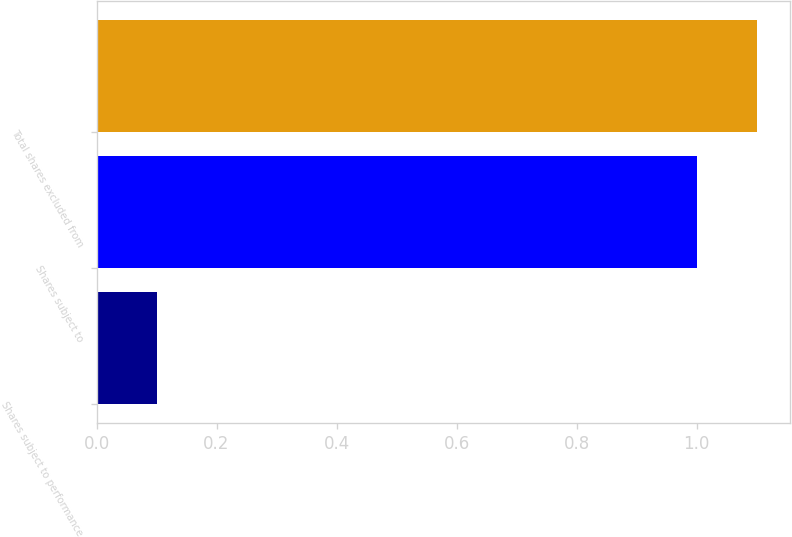Convert chart. <chart><loc_0><loc_0><loc_500><loc_500><bar_chart><fcel>Shares subject to performance<fcel>Shares subject to<fcel>Total shares excluded from<nl><fcel>0.1<fcel>1<fcel>1.1<nl></chart> 